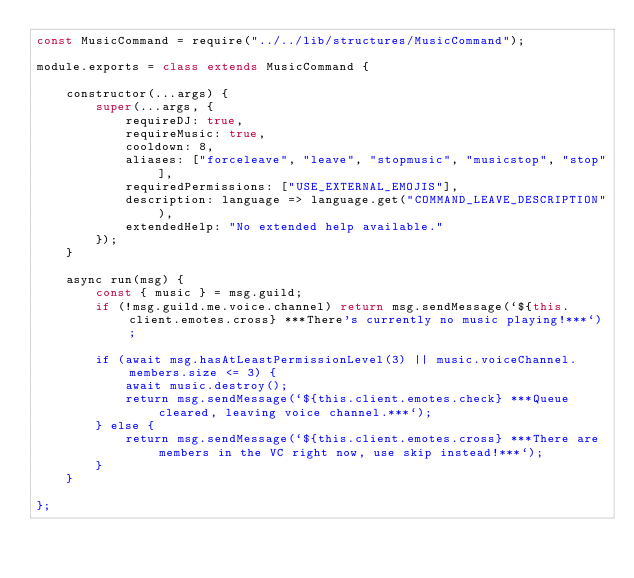<code> <loc_0><loc_0><loc_500><loc_500><_JavaScript_>const MusicCommand = require("../../lib/structures/MusicCommand");

module.exports = class extends MusicCommand {

    constructor(...args) {
        super(...args, {
            requireDJ: true,
            requireMusic: true,
            cooldown: 8,
            aliases: ["forceleave", "leave", "stopmusic", "musicstop", "stop"],
            requiredPermissions: ["USE_EXTERNAL_EMOJIS"],
            description: language => language.get("COMMAND_LEAVE_DESCRIPTION"),
            extendedHelp: "No extended help available."
        });
    }

    async run(msg) {
        const { music } = msg.guild;
        if (!msg.guild.me.voice.channel) return msg.sendMessage(`${this.client.emotes.cross} ***There's currently no music playing!***`);

        if (await msg.hasAtLeastPermissionLevel(3) || music.voiceChannel.members.size <= 3) {
            await music.destroy();
            return msg.sendMessage(`${this.client.emotes.check} ***Queue cleared, leaving voice channel.***`);
        } else {
            return msg.sendMessage(`${this.client.emotes.cross} ***There are members in the VC right now, use skip instead!***`);
        }
    }

};
</code> 